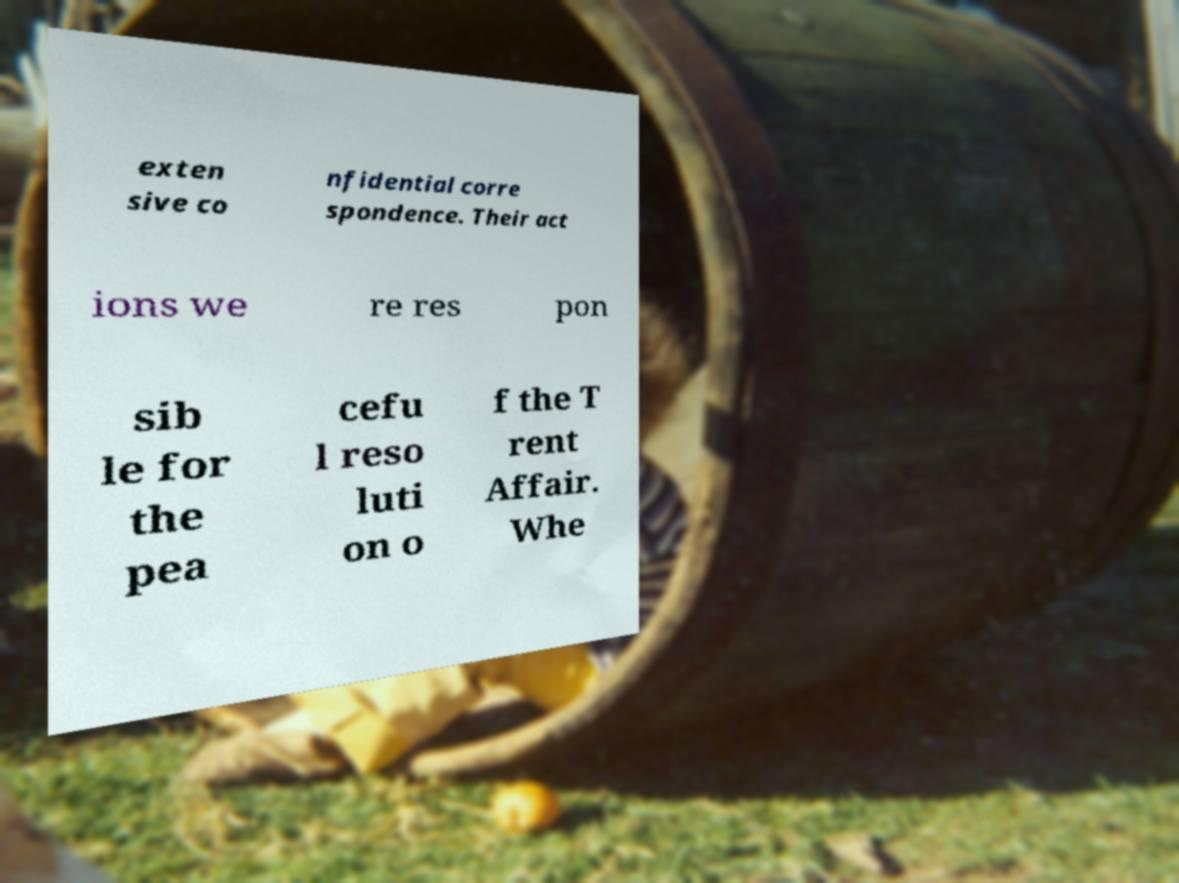Please read and relay the text visible in this image. What does it say? exten sive co nfidential corre spondence. Their act ions we re res pon sib le for the pea cefu l reso luti on o f the T rent Affair. Whe 